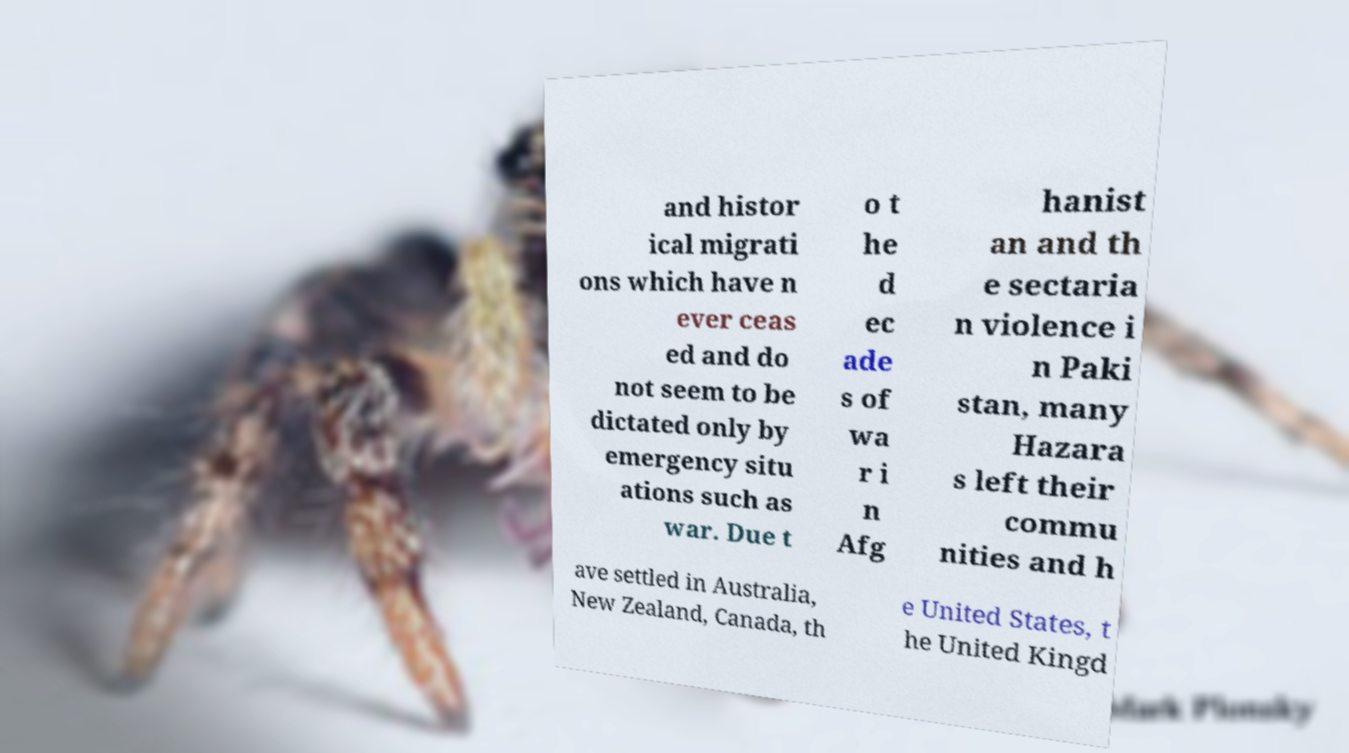What messages or text are displayed in this image? I need them in a readable, typed format. and histor ical migrati ons which have n ever ceas ed and do not seem to be dictated only by emergency situ ations such as war. Due t o t he d ec ade s of wa r i n Afg hanist an and th e sectaria n violence i n Paki stan, many Hazara s left their commu nities and h ave settled in Australia, New Zealand, Canada, th e United States, t he United Kingd 